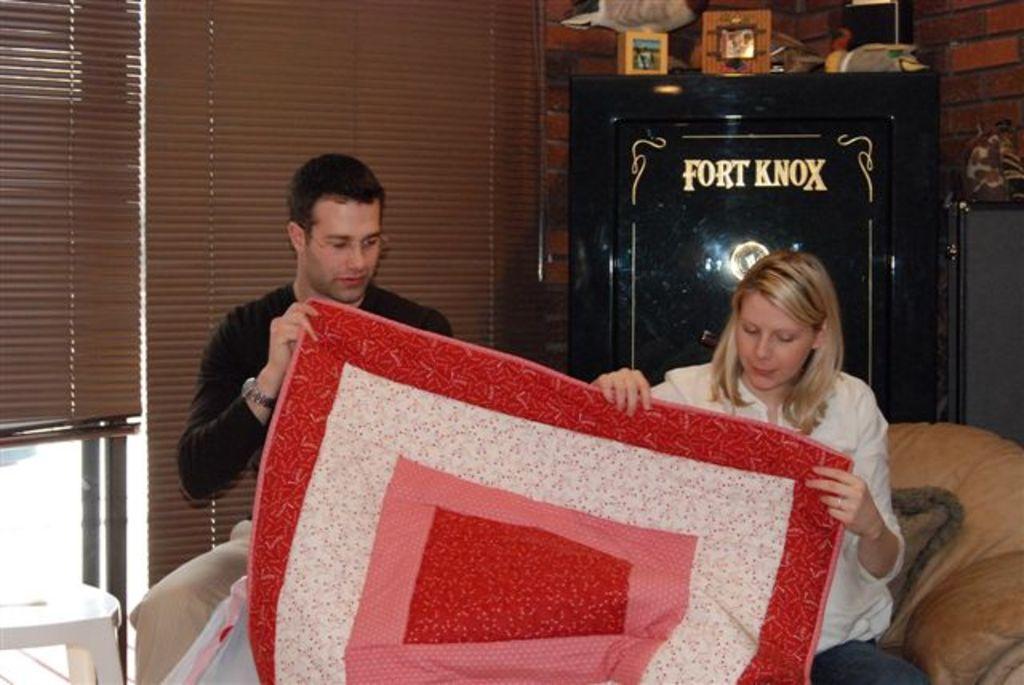Could you give a brief overview of what you see in this image? The picture is taken in a room. In the foreground of the picture there is a man and a woman holding a cloth and sitting in a couch. On the left there is a stool. At the top left there are window blinds and window. At the top right there is a bureau and there are frames and other objects. Behind the bureau there is a brick wall. 